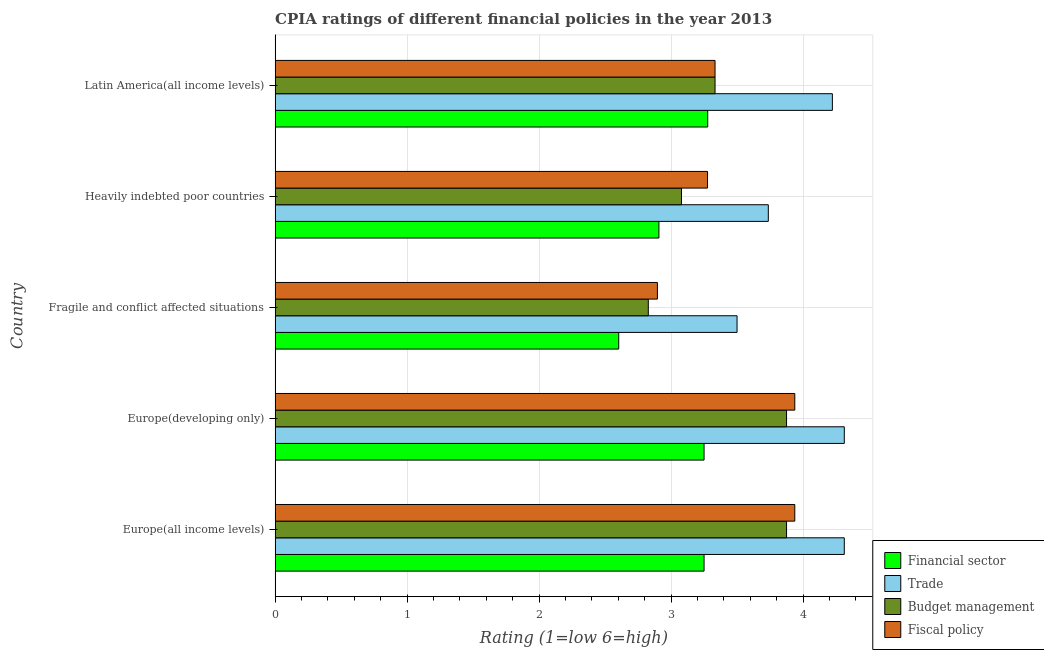How many groups of bars are there?
Your answer should be compact. 5. Are the number of bars on each tick of the Y-axis equal?
Provide a short and direct response. Yes. What is the label of the 2nd group of bars from the top?
Provide a short and direct response. Heavily indebted poor countries. In how many cases, is the number of bars for a given country not equal to the number of legend labels?
Give a very brief answer. 0. What is the cpia rating of trade in Latin America(all income levels)?
Offer a very short reply. 4.22. Across all countries, what is the maximum cpia rating of budget management?
Your answer should be very brief. 3.88. Across all countries, what is the minimum cpia rating of budget management?
Give a very brief answer. 2.83. In which country was the cpia rating of trade maximum?
Offer a terse response. Europe(all income levels). In which country was the cpia rating of trade minimum?
Your response must be concise. Fragile and conflict affected situations. What is the total cpia rating of budget management in the graph?
Give a very brief answer. 16.99. What is the difference between the cpia rating of budget management in Europe(all income levels) and that in Latin America(all income levels)?
Your response must be concise. 0.54. What is the difference between the cpia rating of trade in Europe(developing only) and the cpia rating of budget management in Europe(all income levels)?
Provide a succinct answer. 0.44. What is the average cpia rating of financial sector per country?
Make the answer very short. 3.06. What is the difference between the cpia rating of trade and cpia rating of budget management in Europe(developing only)?
Your answer should be compact. 0.44. In how many countries, is the cpia rating of financial sector greater than 0.6000000000000001 ?
Provide a succinct answer. 5. What is the ratio of the cpia rating of financial sector in Europe(all income levels) to that in Fragile and conflict affected situations?
Keep it short and to the point. 1.25. What is the difference between the highest and the second highest cpia rating of trade?
Your answer should be compact. 0. What is the difference between the highest and the lowest cpia rating of trade?
Make the answer very short. 0.81. In how many countries, is the cpia rating of budget management greater than the average cpia rating of budget management taken over all countries?
Provide a succinct answer. 2. Is the sum of the cpia rating of financial sector in Europe(developing only) and Fragile and conflict affected situations greater than the maximum cpia rating of fiscal policy across all countries?
Your response must be concise. Yes. What does the 4th bar from the top in Europe(developing only) represents?
Provide a succinct answer. Financial sector. What does the 3rd bar from the bottom in Europe(developing only) represents?
Give a very brief answer. Budget management. Are all the bars in the graph horizontal?
Ensure brevity in your answer.  Yes. How many countries are there in the graph?
Your answer should be compact. 5. What is the difference between two consecutive major ticks on the X-axis?
Ensure brevity in your answer.  1. Are the values on the major ticks of X-axis written in scientific E-notation?
Give a very brief answer. No. Does the graph contain grids?
Your answer should be compact. Yes. How many legend labels are there?
Keep it short and to the point. 4. What is the title of the graph?
Make the answer very short. CPIA ratings of different financial policies in the year 2013. What is the label or title of the Y-axis?
Keep it short and to the point. Country. What is the Rating (1=low 6=high) of Trade in Europe(all income levels)?
Your response must be concise. 4.31. What is the Rating (1=low 6=high) of Budget management in Europe(all income levels)?
Your response must be concise. 3.88. What is the Rating (1=low 6=high) in Fiscal policy in Europe(all income levels)?
Provide a short and direct response. 3.94. What is the Rating (1=low 6=high) of Trade in Europe(developing only)?
Your answer should be compact. 4.31. What is the Rating (1=low 6=high) of Budget management in Europe(developing only)?
Offer a terse response. 3.88. What is the Rating (1=low 6=high) in Fiscal policy in Europe(developing only)?
Your answer should be very brief. 3.94. What is the Rating (1=low 6=high) in Financial sector in Fragile and conflict affected situations?
Make the answer very short. 2.6. What is the Rating (1=low 6=high) of Trade in Fragile and conflict affected situations?
Make the answer very short. 3.5. What is the Rating (1=low 6=high) of Budget management in Fragile and conflict affected situations?
Keep it short and to the point. 2.83. What is the Rating (1=low 6=high) of Fiscal policy in Fragile and conflict affected situations?
Give a very brief answer. 2.9. What is the Rating (1=low 6=high) in Financial sector in Heavily indebted poor countries?
Your answer should be compact. 2.91. What is the Rating (1=low 6=high) of Trade in Heavily indebted poor countries?
Keep it short and to the point. 3.74. What is the Rating (1=low 6=high) of Budget management in Heavily indebted poor countries?
Provide a short and direct response. 3.08. What is the Rating (1=low 6=high) of Fiscal policy in Heavily indebted poor countries?
Make the answer very short. 3.28. What is the Rating (1=low 6=high) in Financial sector in Latin America(all income levels)?
Your response must be concise. 3.28. What is the Rating (1=low 6=high) in Trade in Latin America(all income levels)?
Offer a very short reply. 4.22. What is the Rating (1=low 6=high) in Budget management in Latin America(all income levels)?
Make the answer very short. 3.33. What is the Rating (1=low 6=high) of Fiscal policy in Latin America(all income levels)?
Your response must be concise. 3.33. Across all countries, what is the maximum Rating (1=low 6=high) of Financial sector?
Provide a succinct answer. 3.28. Across all countries, what is the maximum Rating (1=low 6=high) of Trade?
Keep it short and to the point. 4.31. Across all countries, what is the maximum Rating (1=low 6=high) in Budget management?
Give a very brief answer. 3.88. Across all countries, what is the maximum Rating (1=low 6=high) in Fiscal policy?
Give a very brief answer. 3.94. Across all countries, what is the minimum Rating (1=low 6=high) in Financial sector?
Your response must be concise. 2.6. Across all countries, what is the minimum Rating (1=low 6=high) in Budget management?
Offer a very short reply. 2.83. Across all countries, what is the minimum Rating (1=low 6=high) of Fiscal policy?
Offer a terse response. 2.9. What is the total Rating (1=low 6=high) in Financial sector in the graph?
Your answer should be very brief. 15.29. What is the total Rating (1=low 6=high) in Trade in the graph?
Your response must be concise. 20.08. What is the total Rating (1=low 6=high) of Budget management in the graph?
Offer a terse response. 16.99. What is the total Rating (1=low 6=high) in Fiscal policy in the graph?
Provide a succinct answer. 17.38. What is the difference between the Rating (1=low 6=high) of Budget management in Europe(all income levels) and that in Europe(developing only)?
Offer a terse response. 0. What is the difference between the Rating (1=low 6=high) in Financial sector in Europe(all income levels) and that in Fragile and conflict affected situations?
Your answer should be very brief. 0.65. What is the difference between the Rating (1=low 6=high) in Trade in Europe(all income levels) and that in Fragile and conflict affected situations?
Give a very brief answer. 0.81. What is the difference between the Rating (1=low 6=high) in Budget management in Europe(all income levels) and that in Fragile and conflict affected situations?
Ensure brevity in your answer.  1.05. What is the difference between the Rating (1=low 6=high) in Fiscal policy in Europe(all income levels) and that in Fragile and conflict affected situations?
Offer a very short reply. 1.04. What is the difference between the Rating (1=low 6=high) in Financial sector in Europe(all income levels) and that in Heavily indebted poor countries?
Your answer should be compact. 0.34. What is the difference between the Rating (1=low 6=high) of Trade in Europe(all income levels) and that in Heavily indebted poor countries?
Make the answer very short. 0.58. What is the difference between the Rating (1=low 6=high) in Budget management in Europe(all income levels) and that in Heavily indebted poor countries?
Provide a short and direct response. 0.8. What is the difference between the Rating (1=low 6=high) in Fiscal policy in Europe(all income levels) and that in Heavily indebted poor countries?
Provide a succinct answer. 0.66. What is the difference between the Rating (1=low 6=high) in Financial sector in Europe(all income levels) and that in Latin America(all income levels)?
Provide a succinct answer. -0.03. What is the difference between the Rating (1=low 6=high) of Trade in Europe(all income levels) and that in Latin America(all income levels)?
Provide a short and direct response. 0.09. What is the difference between the Rating (1=low 6=high) of Budget management in Europe(all income levels) and that in Latin America(all income levels)?
Provide a short and direct response. 0.54. What is the difference between the Rating (1=low 6=high) of Fiscal policy in Europe(all income levels) and that in Latin America(all income levels)?
Provide a succinct answer. 0.6. What is the difference between the Rating (1=low 6=high) of Financial sector in Europe(developing only) and that in Fragile and conflict affected situations?
Offer a very short reply. 0.65. What is the difference between the Rating (1=low 6=high) of Trade in Europe(developing only) and that in Fragile and conflict affected situations?
Offer a terse response. 0.81. What is the difference between the Rating (1=low 6=high) of Budget management in Europe(developing only) and that in Fragile and conflict affected situations?
Provide a succinct answer. 1.05. What is the difference between the Rating (1=low 6=high) in Fiscal policy in Europe(developing only) and that in Fragile and conflict affected situations?
Keep it short and to the point. 1.04. What is the difference between the Rating (1=low 6=high) in Financial sector in Europe(developing only) and that in Heavily indebted poor countries?
Offer a terse response. 0.34. What is the difference between the Rating (1=low 6=high) in Trade in Europe(developing only) and that in Heavily indebted poor countries?
Your answer should be compact. 0.58. What is the difference between the Rating (1=low 6=high) in Budget management in Europe(developing only) and that in Heavily indebted poor countries?
Make the answer very short. 0.8. What is the difference between the Rating (1=low 6=high) in Fiscal policy in Europe(developing only) and that in Heavily indebted poor countries?
Your answer should be very brief. 0.66. What is the difference between the Rating (1=low 6=high) of Financial sector in Europe(developing only) and that in Latin America(all income levels)?
Offer a terse response. -0.03. What is the difference between the Rating (1=low 6=high) in Trade in Europe(developing only) and that in Latin America(all income levels)?
Your answer should be compact. 0.09. What is the difference between the Rating (1=low 6=high) of Budget management in Europe(developing only) and that in Latin America(all income levels)?
Your answer should be very brief. 0.54. What is the difference between the Rating (1=low 6=high) of Fiscal policy in Europe(developing only) and that in Latin America(all income levels)?
Ensure brevity in your answer.  0.6. What is the difference between the Rating (1=low 6=high) of Financial sector in Fragile and conflict affected situations and that in Heavily indebted poor countries?
Your answer should be compact. -0.3. What is the difference between the Rating (1=low 6=high) in Trade in Fragile and conflict affected situations and that in Heavily indebted poor countries?
Your answer should be very brief. -0.24. What is the difference between the Rating (1=low 6=high) in Budget management in Fragile and conflict affected situations and that in Heavily indebted poor countries?
Make the answer very short. -0.25. What is the difference between the Rating (1=low 6=high) in Fiscal policy in Fragile and conflict affected situations and that in Heavily indebted poor countries?
Your answer should be compact. -0.38. What is the difference between the Rating (1=low 6=high) in Financial sector in Fragile and conflict affected situations and that in Latin America(all income levels)?
Provide a short and direct response. -0.67. What is the difference between the Rating (1=low 6=high) in Trade in Fragile and conflict affected situations and that in Latin America(all income levels)?
Your answer should be very brief. -0.72. What is the difference between the Rating (1=low 6=high) of Budget management in Fragile and conflict affected situations and that in Latin America(all income levels)?
Ensure brevity in your answer.  -0.51. What is the difference between the Rating (1=low 6=high) of Fiscal policy in Fragile and conflict affected situations and that in Latin America(all income levels)?
Ensure brevity in your answer.  -0.44. What is the difference between the Rating (1=low 6=high) of Financial sector in Heavily indebted poor countries and that in Latin America(all income levels)?
Keep it short and to the point. -0.37. What is the difference between the Rating (1=low 6=high) of Trade in Heavily indebted poor countries and that in Latin America(all income levels)?
Provide a short and direct response. -0.49. What is the difference between the Rating (1=low 6=high) in Budget management in Heavily indebted poor countries and that in Latin America(all income levels)?
Offer a very short reply. -0.25. What is the difference between the Rating (1=low 6=high) in Fiscal policy in Heavily indebted poor countries and that in Latin America(all income levels)?
Make the answer very short. -0.06. What is the difference between the Rating (1=low 6=high) in Financial sector in Europe(all income levels) and the Rating (1=low 6=high) in Trade in Europe(developing only)?
Your response must be concise. -1.06. What is the difference between the Rating (1=low 6=high) of Financial sector in Europe(all income levels) and the Rating (1=low 6=high) of Budget management in Europe(developing only)?
Provide a succinct answer. -0.62. What is the difference between the Rating (1=low 6=high) of Financial sector in Europe(all income levels) and the Rating (1=low 6=high) of Fiscal policy in Europe(developing only)?
Your answer should be very brief. -0.69. What is the difference between the Rating (1=low 6=high) of Trade in Europe(all income levels) and the Rating (1=low 6=high) of Budget management in Europe(developing only)?
Keep it short and to the point. 0.44. What is the difference between the Rating (1=low 6=high) of Budget management in Europe(all income levels) and the Rating (1=low 6=high) of Fiscal policy in Europe(developing only)?
Your answer should be very brief. -0.06. What is the difference between the Rating (1=low 6=high) of Financial sector in Europe(all income levels) and the Rating (1=low 6=high) of Budget management in Fragile and conflict affected situations?
Offer a terse response. 0.42. What is the difference between the Rating (1=low 6=high) in Financial sector in Europe(all income levels) and the Rating (1=low 6=high) in Fiscal policy in Fragile and conflict affected situations?
Provide a succinct answer. 0.35. What is the difference between the Rating (1=low 6=high) of Trade in Europe(all income levels) and the Rating (1=low 6=high) of Budget management in Fragile and conflict affected situations?
Your answer should be very brief. 1.48. What is the difference between the Rating (1=low 6=high) in Trade in Europe(all income levels) and the Rating (1=low 6=high) in Fiscal policy in Fragile and conflict affected situations?
Give a very brief answer. 1.42. What is the difference between the Rating (1=low 6=high) of Budget management in Europe(all income levels) and the Rating (1=low 6=high) of Fiscal policy in Fragile and conflict affected situations?
Your answer should be very brief. 0.98. What is the difference between the Rating (1=low 6=high) of Financial sector in Europe(all income levels) and the Rating (1=low 6=high) of Trade in Heavily indebted poor countries?
Provide a succinct answer. -0.49. What is the difference between the Rating (1=low 6=high) in Financial sector in Europe(all income levels) and the Rating (1=low 6=high) in Budget management in Heavily indebted poor countries?
Your answer should be very brief. 0.17. What is the difference between the Rating (1=low 6=high) of Financial sector in Europe(all income levels) and the Rating (1=low 6=high) of Fiscal policy in Heavily indebted poor countries?
Provide a short and direct response. -0.03. What is the difference between the Rating (1=low 6=high) in Trade in Europe(all income levels) and the Rating (1=low 6=high) in Budget management in Heavily indebted poor countries?
Ensure brevity in your answer.  1.23. What is the difference between the Rating (1=low 6=high) in Trade in Europe(all income levels) and the Rating (1=low 6=high) in Fiscal policy in Heavily indebted poor countries?
Your answer should be very brief. 1.04. What is the difference between the Rating (1=low 6=high) of Budget management in Europe(all income levels) and the Rating (1=low 6=high) of Fiscal policy in Heavily indebted poor countries?
Your answer should be very brief. 0.6. What is the difference between the Rating (1=low 6=high) in Financial sector in Europe(all income levels) and the Rating (1=low 6=high) in Trade in Latin America(all income levels)?
Ensure brevity in your answer.  -0.97. What is the difference between the Rating (1=low 6=high) of Financial sector in Europe(all income levels) and the Rating (1=low 6=high) of Budget management in Latin America(all income levels)?
Your response must be concise. -0.08. What is the difference between the Rating (1=low 6=high) in Financial sector in Europe(all income levels) and the Rating (1=low 6=high) in Fiscal policy in Latin America(all income levels)?
Your answer should be compact. -0.08. What is the difference between the Rating (1=low 6=high) in Trade in Europe(all income levels) and the Rating (1=low 6=high) in Budget management in Latin America(all income levels)?
Give a very brief answer. 0.98. What is the difference between the Rating (1=low 6=high) of Trade in Europe(all income levels) and the Rating (1=low 6=high) of Fiscal policy in Latin America(all income levels)?
Make the answer very short. 0.98. What is the difference between the Rating (1=low 6=high) in Budget management in Europe(all income levels) and the Rating (1=low 6=high) in Fiscal policy in Latin America(all income levels)?
Your response must be concise. 0.54. What is the difference between the Rating (1=low 6=high) of Financial sector in Europe(developing only) and the Rating (1=low 6=high) of Trade in Fragile and conflict affected situations?
Provide a short and direct response. -0.25. What is the difference between the Rating (1=low 6=high) of Financial sector in Europe(developing only) and the Rating (1=low 6=high) of Budget management in Fragile and conflict affected situations?
Your answer should be very brief. 0.42. What is the difference between the Rating (1=low 6=high) of Financial sector in Europe(developing only) and the Rating (1=low 6=high) of Fiscal policy in Fragile and conflict affected situations?
Give a very brief answer. 0.35. What is the difference between the Rating (1=low 6=high) of Trade in Europe(developing only) and the Rating (1=low 6=high) of Budget management in Fragile and conflict affected situations?
Offer a terse response. 1.48. What is the difference between the Rating (1=low 6=high) of Trade in Europe(developing only) and the Rating (1=low 6=high) of Fiscal policy in Fragile and conflict affected situations?
Keep it short and to the point. 1.42. What is the difference between the Rating (1=low 6=high) in Budget management in Europe(developing only) and the Rating (1=low 6=high) in Fiscal policy in Fragile and conflict affected situations?
Offer a very short reply. 0.98. What is the difference between the Rating (1=low 6=high) in Financial sector in Europe(developing only) and the Rating (1=low 6=high) in Trade in Heavily indebted poor countries?
Your answer should be compact. -0.49. What is the difference between the Rating (1=low 6=high) in Financial sector in Europe(developing only) and the Rating (1=low 6=high) in Budget management in Heavily indebted poor countries?
Offer a terse response. 0.17. What is the difference between the Rating (1=low 6=high) in Financial sector in Europe(developing only) and the Rating (1=low 6=high) in Fiscal policy in Heavily indebted poor countries?
Offer a very short reply. -0.03. What is the difference between the Rating (1=low 6=high) of Trade in Europe(developing only) and the Rating (1=low 6=high) of Budget management in Heavily indebted poor countries?
Give a very brief answer. 1.23. What is the difference between the Rating (1=low 6=high) of Trade in Europe(developing only) and the Rating (1=low 6=high) of Fiscal policy in Heavily indebted poor countries?
Offer a terse response. 1.04. What is the difference between the Rating (1=low 6=high) in Budget management in Europe(developing only) and the Rating (1=low 6=high) in Fiscal policy in Heavily indebted poor countries?
Your answer should be compact. 0.6. What is the difference between the Rating (1=low 6=high) in Financial sector in Europe(developing only) and the Rating (1=low 6=high) in Trade in Latin America(all income levels)?
Keep it short and to the point. -0.97. What is the difference between the Rating (1=low 6=high) in Financial sector in Europe(developing only) and the Rating (1=low 6=high) in Budget management in Latin America(all income levels)?
Keep it short and to the point. -0.08. What is the difference between the Rating (1=low 6=high) of Financial sector in Europe(developing only) and the Rating (1=low 6=high) of Fiscal policy in Latin America(all income levels)?
Your response must be concise. -0.08. What is the difference between the Rating (1=low 6=high) of Trade in Europe(developing only) and the Rating (1=low 6=high) of Budget management in Latin America(all income levels)?
Offer a very short reply. 0.98. What is the difference between the Rating (1=low 6=high) of Trade in Europe(developing only) and the Rating (1=low 6=high) of Fiscal policy in Latin America(all income levels)?
Ensure brevity in your answer.  0.98. What is the difference between the Rating (1=low 6=high) in Budget management in Europe(developing only) and the Rating (1=low 6=high) in Fiscal policy in Latin America(all income levels)?
Offer a very short reply. 0.54. What is the difference between the Rating (1=low 6=high) of Financial sector in Fragile and conflict affected situations and the Rating (1=low 6=high) of Trade in Heavily indebted poor countries?
Provide a short and direct response. -1.13. What is the difference between the Rating (1=low 6=high) of Financial sector in Fragile and conflict affected situations and the Rating (1=low 6=high) of Budget management in Heavily indebted poor countries?
Provide a succinct answer. -0.48. What is the difference between the Rating (1=low 6=high) in Financial sector in Fragile and conflict affected situations and the Rating (1=low 6=high) in Fiscal policy in Heavily indebted poor countries?
Your response must be concise. -0.67. What is the difference between the Rating (1=low 6=high) of Trade in Fragile and conflict affected situations and the Rating (1=low 6=high) of Budget management in Heavily indebted poor countries?
Offer a terse response. 0.42. What is the difference between the Rating (1=low 6=high) of Trade in Fragile and conflict affected situations and the Rating (1=low 6=high) of Fiscal policy in Heavily indebted poor countries?
Offer a very short reply. 0.22. What is the difference between the Rating (1=low 6=high) of Budget management in Fragile and conflict affected situations and the Rating (1=low 6=high) of Fiscal policy in Heavily indebted poor countries?
Offer a terse response. -0.45. What is the difference between the Rating (1=low 6=high) in Financial sector in Fragile and conflict affected situations and the Rating (1=low 6=high) in Trade in Latin America(all income levels)?
Your answer should be compact. -1.62. What is the difference between the Rating (1=low 6=high) in Financial sector in Fragile and conflict affected situations and the Rating (1=low 6=high) in Budget management in Latin America(all income levels)?
Your response must be concise. -0.73. What is the difference between the Rating (1=low 6=high) of Financial sector in Fragile and conflict affected situations and the Rating (1=low 6=high) of Fiscal policy in Latin America(all income levels)?
Your answer should be compact. -0.73. What is the difference between the Rating (1=low 6=high) in Budget management in Fragile and conflict affected situations and the Rating (1=low 6=high) in Fiscal policy in Latin America(all income levels)?
Ensure brevity in your answer.  -0.51. What is the difference between the Rating (1=low 6=high) of Financial sector in Heavily indebted poor countries and the Rating (1=low 6=high) of Trade in Latin America(all income levels)?
Your answer should be compact. -1.31. What is the difference between the Rating (1=low 6=high) in Financial sector in Heavily indebted poor countries and the Rating (1=low 6=high) in Budget management in Latin America(all income levels)?
Your response must be concise. -0.43. What is the difference between the Rating (1=low 6=high) of Financial sector in Heavily indebted poor countries and the Rating (1=low 6=high) of Fiscal policy in Latin America(all income levels)?
Ensure brevity in your answer.  -0.43. What is the difference between the Rating (1=low 6=high) of Trade in Heavily indebted poor countries and the Rating (1=low 6=high) of Budget management in Latin America(all income levels)?
Your answer should be very brief. 0.4. What is the difference between the Rating (1=low 6=high) in Trade in Heavily indebted poor countries and the Rating (1=low 6=high) in Fiscal policy in Latin America(all income levels)?
Your answer should be compact. 0.4. What is the difference between the Rating (1=low 6=high) in Budget management in Heavily indebted poor countries and the Rating (1=low 6=high) in Fiscal policy in Latin America(all income levels)?
Give a very brief answer. -0.25. What is the average Rating (1=low 6=high) of Financial sector per country?
Offer a very short reply. 3.06. What is the average Rating (1=low 6=high) in Trade per country?
Offer a terse response. 4.02. What is the average Rating (1=low 6=high) of Budget management per country?
Give a very brief answer. 3.4. What is the average Rating (1=low 6=high) in Fiscal policy per country?
Offer a terse response. 3.48. What is the difference between the Rating (1=low 6=high) in Financial sector and Rating (1=low 6=high) in Trade in Europe(all income levels)?
Your response must be concise. -1.06. What is the difference between the Rating (1=low 6=high) of Financial sector and Rating (1=low 6=high) of Budget management in Europe(all income levels)?
Make the answer very short. -0.62. What is the difference between the Rating (1=low 6=high) in Financial sector and Rating (1=low 6=high) in Fiscal policy in Europe(all income levels)?
Offer a terse response. -0.69. What is the difference between the Rating (1=low 6=high) in Trade and Rating (1=low 6=high) in Budget management in Europe(all income levels)?
Keep it short and to the point. 0.44. What is the difference between the Rating (1=low 6=high) in Budget management and Rating (1=low 6=high) in Fiscal policy in Europe(all income levels)?
Make the answer very short. -0.06. What is the difference between the Rating (1=low 6=high) in Financial sector and Rating (1=low 6=high) in Trade in Europe(developing only)?
Provide a short and direct response. -1.06. What is the difference between the Rating (1=low 6=high) of Financial sector and Rating (1=low 6=high) of Budget management in Europe(developing only)?
Your answer should be very brief. -0.62. What is the difference between the Rating (1=low 6=high) in Financial sector and Rating (1=low 6=high) in Fiscal policy in Europe(developing only)?
Offer a very short reply. -0.69. What is the difference between the Rating (1=low 6=high) of Trade and Rating (1=low 6=high) of Budget management in Europe(developing only)?
Keep it short and to the point. 0.44. What is the difference between the Rating (1=low 6=high) in Budget management and Rating (1=low 6=high) in Fiscal policy in Europe(developing only)?
Provide a short and direct response. -0.06. What is the difference between the Rating (1=low 6=high) of Financial sector and Rating (1=low 6=high) of Trade in Fragile and conflict affected situations?
Your answer should be compact. -0.9. What is the difference between the Rating (1=low 6=high) in Financial sector and Rating (1=low 6=high) in Budget management in Fragile and conflict affected situations?
Your answer should be compact. -0.22. What is the difference between the Rating (1=low 6=high) in Financial sector and Rating (1=low 6=high) in Fiscal policy in Fragile and conflict affected situations?
Keep it short and to the point. -0.29. What is the difference between the Rating (1=low 6=high) in Trade and Rating (1=low 6=high) in Budget management in Fragile and conflict affected situations?
Give a very brief answer. 0.67. What is the difference between the Rating (1=low 6=high) of Trade and Rating (1=low 6=high) of Fiscal policy in Fragile and conflict affected situations?
Give a very brief answer. 0.6. What is the difference between the Rating (1=low 6=high) of Budget management and Rating (1=low 6=high) of Fiscal policy in Fragile and conflict affected situations?
Provide a short and direct response. -0.07. What is the difference between the Rating (1=low 6=high) of Financial sector and Rating (1=low 6=high) of Trade in Heavily indebted poor countries?
Your answer should be very brief. -0.83. What is the difference between the Rating (1=low 6=high) in Financial sector and Rating (1=low 6=high) in Budget management in Heavily indebted poor countries?
Your answer should be compact. -0.17. What is the difference between the Rating (1=low 6=high) of Financial sector and Rating (1=low 6=high) of Fiscal policy in Heavily indebted poor countries?
Provide a short and direct response. -0.37. What is the difference between the Rating (1=low 6=high) in Trade and Rating (1=low 6=high) in Budget management in Heavily indebted poor countries?
Your answer should be compact. 0.66. What is the difference between the Rating (1=low 6=high) of Trade and Rating (1=low 6=high) of Fiscal policy in Heavily indebted poor countries?
Your response must be concise. 0.46. What is the difference between the Rating (1=low 6=high) of Budget management and Rating (1=low 6=high) of Fiscal policy in Heavily indebted poor countries?
Your answer should be very brief. -0.2. What is the difference between the Rating (1=low 6=high) of Financial sector and Rating (1=low 6=high) of Trade in Latin America(all income levels)?
Your answer should be compact. -0.94. What is the difference between the Rating (1=low 6=high) of Financial sector and Rating (1=low 6=high) of Budget management in Latin America(all income levels)?
Your response must be concise. -0.06. What is the difference between the Rating (1=low 6=high) of Financial sector and Rating (1=low 6=high) of Fiscal policy in Latin America(all income levels)?
Offer a terse response. -0.06. What is the difference between the Rating (1=low 6=high) of Budget management and Rating (1=low 6=high) of Fiscal policy in Latin America(all income levels)?
Ensure brevity in your answer.  0. What is the ratio of the Rating (1=low 6=high) in Trade in Europe(all income levels) to that in Europe(developing only)?
Offer a very short reply. 1. What is the ratio of the Rating (1=low 6=high) in Budget management in Europe(all income levels) to that in Europe(developing only)?
Offer a very short reply. 1. What is the ratio of the Rating (1=low 6=high) of Fiscal policy in Europe(all income levels) to that in Europe(developing only)?
Ensure brevity in your answer.  1. What is the ratio of the Rating (1=low 6=high) in Financial sector in Europe(all income levels) to that in Fragile and conflict affected situations?
Make the answer very short. 1.25. What is the ratio of the Rating (1=low 6=high) in Trade in Europe(all income levels) to that in Fragile and conflict affected situations?
Your response must be concise. 1.23. What is the ratio of the Rating (1=low 6=high) of Budget management in Europe(all income levels) to that in Fragile and conflict affected situations?
Offer a very short reply. 1.37. What is the ratio of the Rating (1=low 6=high) in Fiscal policy in Europe(all income levels) to that in Fragile and conflict affected situations?
Provide a short and direct response. 1.36. What is the ratio of the Rating (1=low 6=high) in Financial sector in Europe(all income levels) to that in Heavily indebted poor countries?
Keep it short and to the point. 1.12. What is the ratio of the Rating (1=low 6=high) in Trade in Europe(all income levels) to that in Heavily indebted poor countries?
Your response must be concise. 1.15. What is the ratio of the Rating (1=low 6=high) in Budget management in Europe(all income levels) to that in Heavily indebted poor countries?
Your response must be concise. 1.26. What is the ratio of the Rating (1=low 6=high) in Fiscal policy in Europe(all income levels) to that in Heavily indebted poor countries?
Your response must be concise. 1.2. What is the ratio of the Rating (1=low 6=high) in Financial sector in Europe(all income levels) to that in Latin America(all income levels)?
Make the answer very short. 0.99. What is the ratio of the Rating (1=low 6=high) in Trade in Europe(all income levels) to that in Latin America(all income levels)?
Offer a very short reply. 1.02. What is the ratio of the Rating (1=low 6=high) in Budget management in Europe(all income levels) to that in Latin America(all income levels)?
Provide a succinct answer. 1.16. What is the ratio of the Rating (1=low 6=high) of Fiscal policy in Europe(all income levels) to that in Latin America(all income levels)?
Your answer should be very brief. 1.18. What is the ratio of the Rating (1=low 6=high) of Financial sector in Europe(developing only) to that in Fragile and conflict affected situations?
Provide a succinct answer. 1.25. What is the ratio of the Rating (1=low 6=high) in Trade in Europe(developing only) to that in Fragile and conflict affected situations?
Offer a very short reply. 1.23. What is the ratio of the Rating (1=low 6=high) of Budget management in Europe(developing only) to that in Fragile and conflict affected situations?
Ensure brevity in your answer.  1.37. What is the ratio of the Rating (1=low 6=high) in Fiscal policy in Europe(developing only) to that in Fragile and conflict affected situations?
Your response must be concise. 1.36. What is the ratio of the Rating (1=low 6=high) of Financial sector in Europe(developing only) to that in Heavily indebted poor countries?
Keep it short and to the point. 1.12. What is the ratio of the Rating (1=low 6=high) of Trade in Europe(developing only) to that in Heavily indebted poor countries?
Ensure brevity in your answer.  1.15. What is the ratio of the Rating (1=low 6=high) in Budget management in Europe(developing only) to that in Heavily indebted poor countries?
Offer a very short reply. 1.26. What is the ratio of the Rating (1=low 6=high) in Fiscal policy in Europe(developing only) to that in Heavily indebted poor countries?
Your answer should be very brief. 1.2. What is the ratio of the Rating (1=low 6=high) in Financial sector in Europe(developing only) to that in Latin America(all income levels)?
Provide a succinct answer. 0.99. What is the ratio of the Rating (1=low 6=high) of Trade in Europe(developing only) to that in Latin America(all income levels)?
Give a very brief answer. 1.02. What is the ratio of the Rating (1=low 6=high) of Budget management in Europe(developing only) to that in Latin America(all income levels)?
Offer a terse response. 1.16. What is the ratio of the Rating (1=low 6=high) of Fiscal policy in Europe(developing only) to that in Latin America(all income levels)?
Your answer should be compact. 1.18. What is the ratio of the Rating (1=low 6=high) of Financial sector in Fragile and conflict affected situations to that in Heavily indebted poor countries?
Provide a short and direct response. 0.9. What is the ratio of the Rating (1=low 6=high) of Trade in Fragile and conflict affected situations to that in Heavily indebted poor countries?
Your answer should be compact. 0.94. What is the ratio of the Rating (1=low 6=high) in Budget management in Fragile and conflict affected situations to that in Heavily indebted poor countries?
Your answer should be compact. 0.92. What is the ratio of the Rating (1=low 6=high) of Fiscal policy in Fragile and conflict affected situations to that in Heavily indebted poor countries?
Offer a very short reply. 0.88. What is the ratio of the Rating (1=low 6=high) of Financial sector in Fragile and conflict affected situations to that in Latin America(all income levels)?
Make the answer very short. 0.79. What is the ratio of the Rating (1=low 6=high) in Trade in Fragile and conflict affected situations to that in Latin America(all income levels)?
Your answer should be compact. 0.83. What is the ratio of the Rating (1=low 6=high) of Budget management in Fragile and conflict affected situations to that in Latin America(all income levels)?
Keep it short and to the point. 0.85. What is the ratio of the Rating (1=low 6=high) in Fiscal policy in Fragile and conflict affected situations to that in Latin America(all income levels)?
Your response must be concise. 0.87. What is the ratio of the Rating (1=low 6=high) in Financial sector in Heavily indebted poor countries to that in Latin America(all income levels)?
Your answer should be very brief. 0.89. What is the ratio of the Rating (1=low 6=high) of Trade in Heavily indebted poor countries to that in Latin America(all income levels)?
Keep it short and to the point. 0.89. What is the ratio of the Rating (1=low 6=high) in Budget management in Heavily indebted poor countries to that in Latin America(all income levels)?
Your answer should be very brief. 0.92. What is the ratio of the Rating (1=low 6=high) of Fiscal policy in Heavily indebted poor countries to that in Latin America(all income levels)?
Keep it short and to the point. 0.98. What is the difference between the highest and the second highest Rating (1=low 6=high) of Financial sector?
Give a very brief answer. 0.03. What is the difference between the highest and the lowest Rating (1=low 6=high) of Financial sector?
Offer a very short reply. 0.67. What is the difference between the highest and the lowest Rating (1=low 6=high) in Trade?
Provide a succinct answer. 0.81. What is the difference between the highest and the lowest Rating (1=low 6=high) in Budget management?
Your response must be concise. 1.05. What is the difference between the highest and the lowest Rating (1=low 6=high) of Fiscal policy?
Keep it short and to the point. 1.04. 